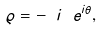Convert formula to latex. <formula><loc_0><loc_0><loc_500><loc_500>\varrho = - \ i \ e ^ { i \theta } ,</formula> 